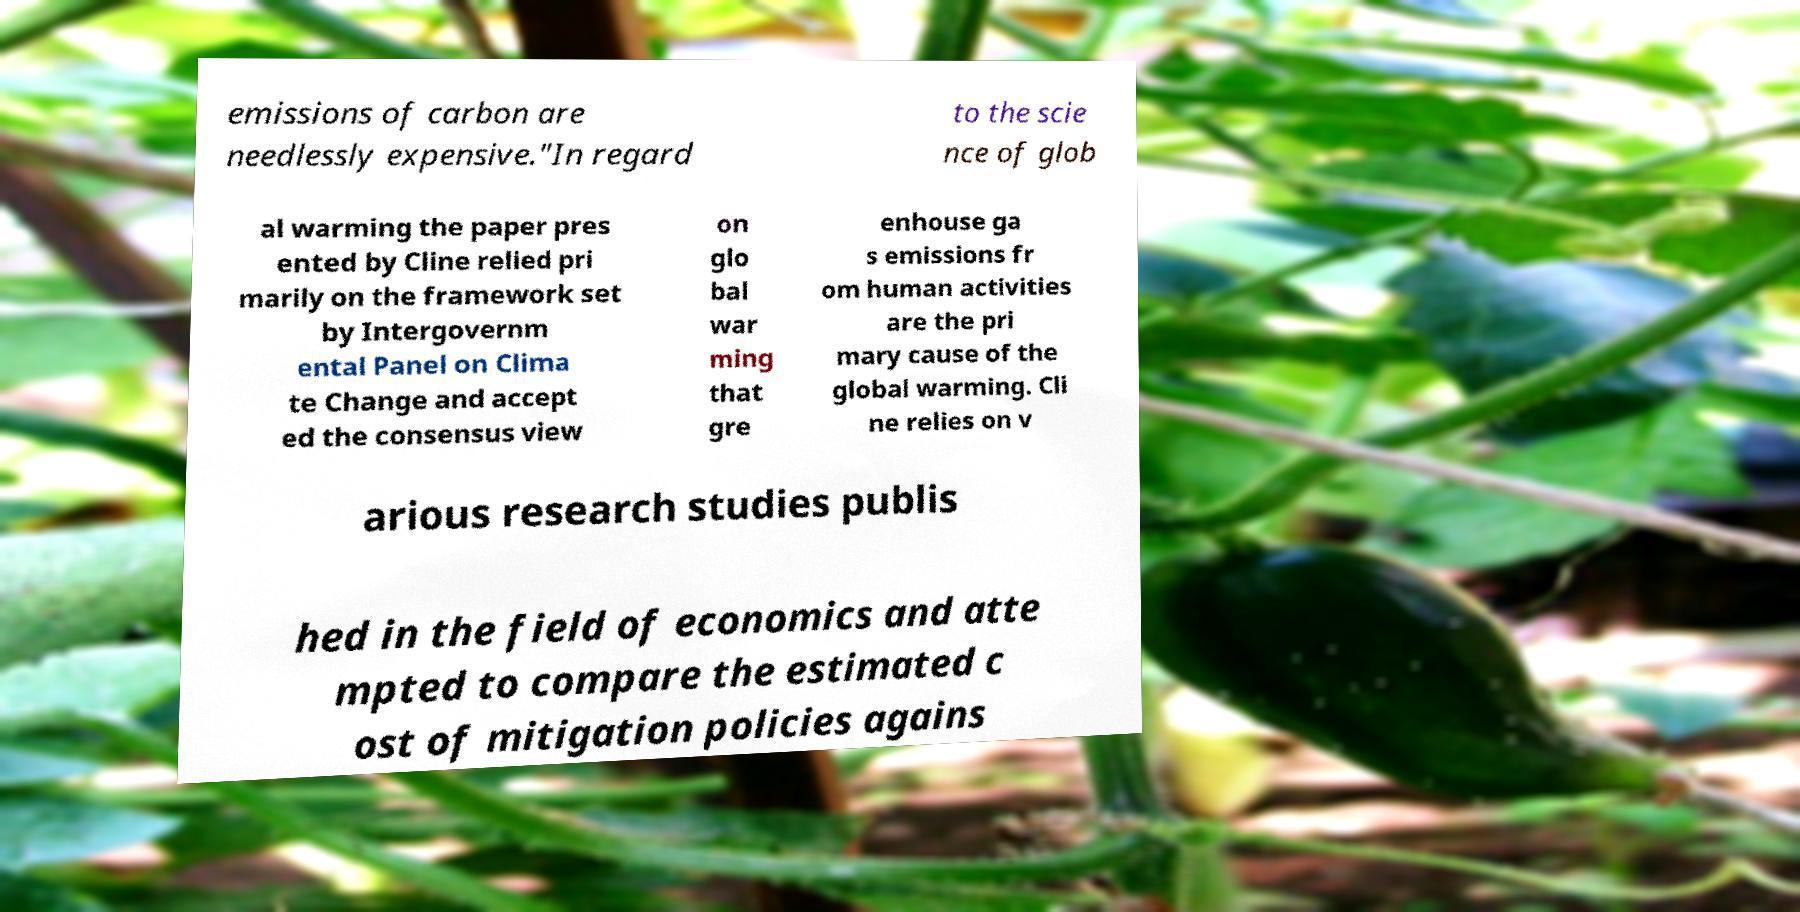Could you assist in decoding the text presented in this image and type it out clearly? emissions of carbon are needlessly expensive."In regard to the scie nce of glob al warming the paper pres ented by Cline relied pri marily on the framework set by Intergovernm ental Panel on Clima te Change and accept ed the consensus view on glo bal war ming that gre enhouse ga s emissions fr om human activities are the pri mary cause of the global warming. Cli ne relies on v arious research studies publis hed in the field of economics and atte mpted to compare the estimated c ost of mitigation policies agains 